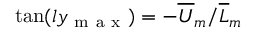Convert formula to latex. <formula><loc_0><loc_0><loc_500><loc_500>\tan ( l y _ { m a x } ) = - { \overline { U } _ { m } } / { \overline { L } _ { m } }</formula> 